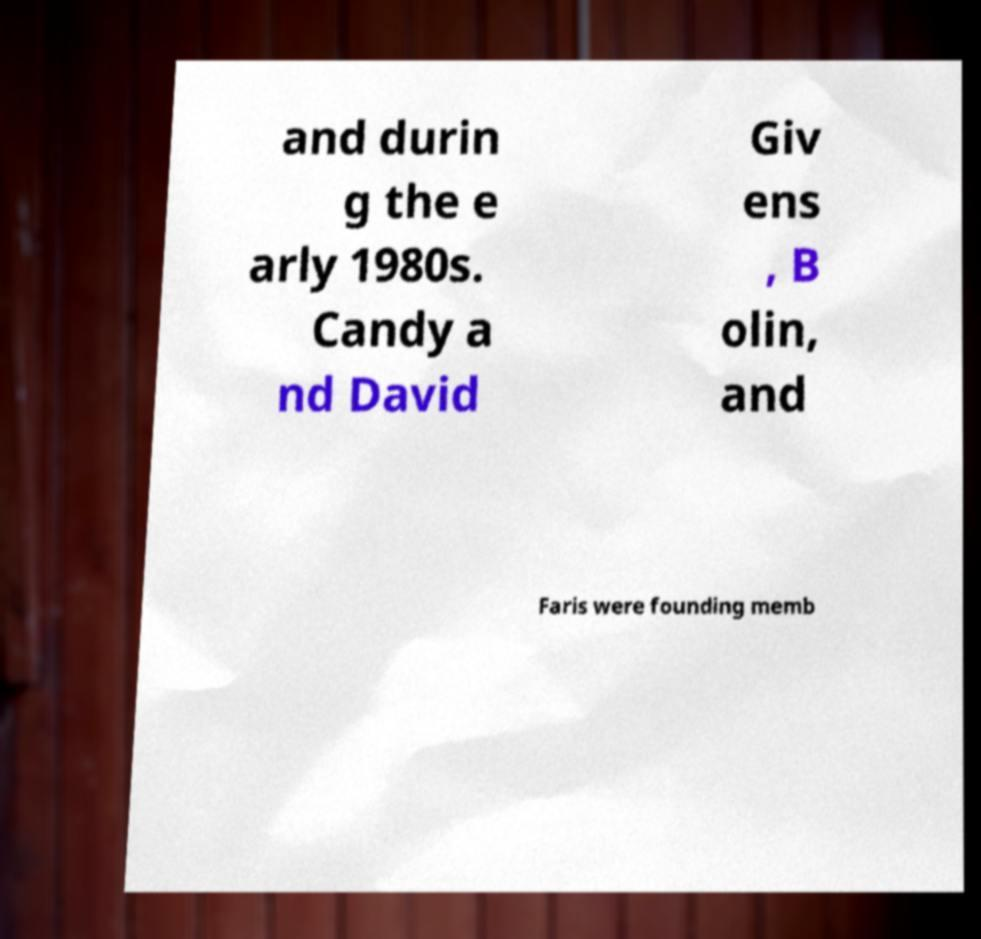Please read and relay the text visible in this image. What does it say? and durin g the e arly 1980s. Candy a nd David Giv ens , B olin, and Faris were founding memb 